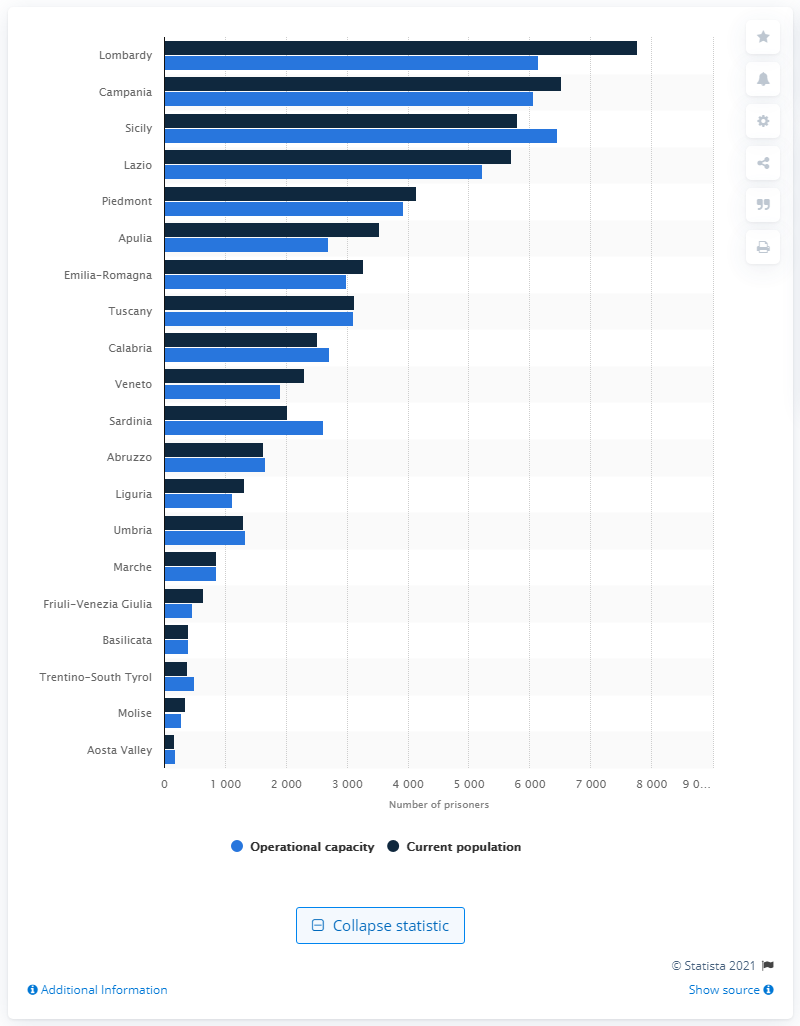Specify some key components in this picture. The region of Lombardy was by far the most populous region in Italy. According to the latest data as of February 2021, the Italian region with the highest number of prisoners was Lombardy. In February 2021, the prison population of Lombardy was 7,766 individuals. 